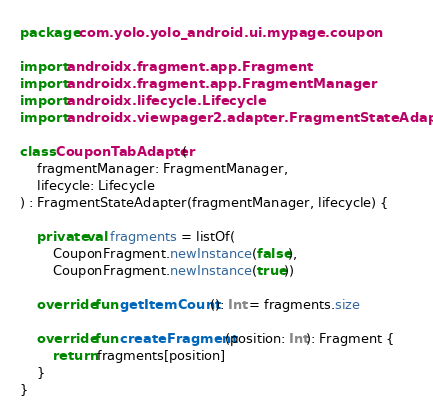<code> <loc_0><loc_0><loc_500><loc_500><_Kotlin_>package com.yolo.yolo_android.ui.mypage.coupon

import androidx.fragment.app.Fragment
import androidx.fragment.app.FragmentManager
import androidx.lifecycle.Lifecycle
import androidx.viewpager2.adapter.FragmentStateAdapter

class CouponTabAdapter(
    fragmentManager: FragmentManager,
    lifecycle: Lifecycle
) : FragmentStateAdapter(fragmentManager, lifecycle) {

    private val fragments = listOf(
        CouponFragment.newInstance(false),
        CouponFragment.newInstance(true))

    override fun getItemCount(): Int = fragments.size

    override fun createFragment(position: Int): Fragment {
        return fragments[position]
    }
}</code> 